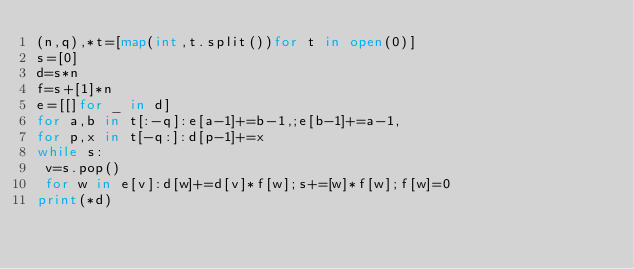<code> <loc_0><loc_0><loc_500><loc_500><_Python_>(n,q),*t=[map(int,t.split())for t in open(0)]
s=[0]
d=s*n
f=s+[1]*n
e=[[]for _ in d]
for a,b in t[:-q]:e[a-1]+=b-1,;e[b-1]+=a-1,
for p,x in t[-q:]:d[p-1]+=x
while s:
 v=s.pop()
 for w in e[v]:d[w]+=d[v]*f[w];s+=[w]*f[w];f[w]=0
print(*d)</code> 